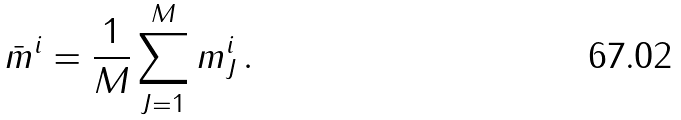<formula> <loc_0><loc_0><loc_500><loc_500>\bar { m } ^ { i } = \frac { 1 } { M } \sum _ { J = 1 } ^ { M } m _ { J } ^ { i } \, .</formula> 